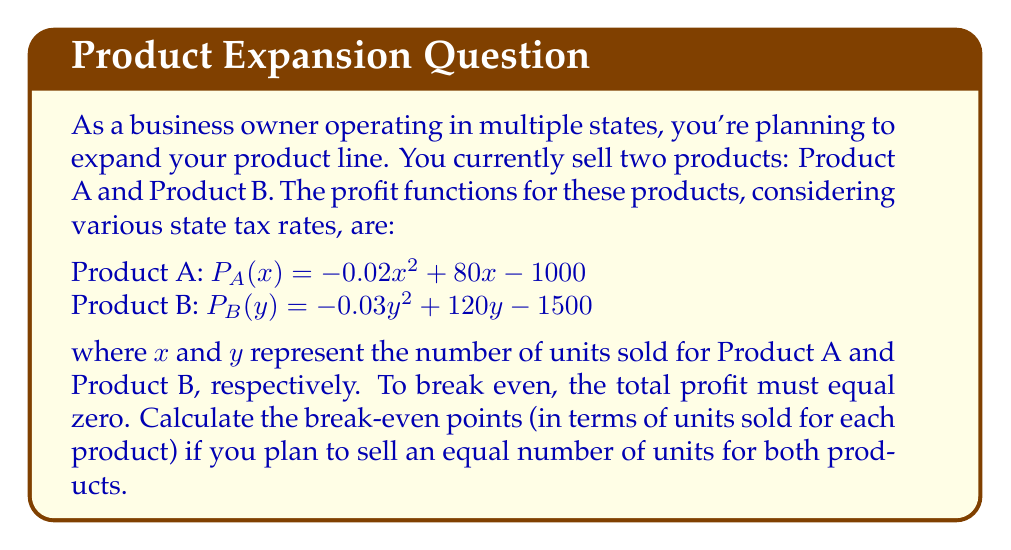Help me with this question. Let's approach this step-by-step:

1) We need to find the values of $x$ and $y$ where the total profit is zero and $x = y$. This can be expressed as:

   $P_A(x) + P_B(y) = 0$ and $x = y$

2) Substituting the given profit functions:

   $(-0.02x^2 + 80x - 1000) + (-0.03y^2 + 120y - 1500) = 0$

3) Since $x = y$, we can replace $y$ with $x$:

   $(-0.02x^2 + 80x - 1000) + (-0.03x^2 + 120x - 1500) = 0$

4) Simplify by combining like terms:

   $-0.05x^2 + 200x - 2500 = 0$

5) This is a quadratic equation in the standard form $ax^2 + bx + c = 0$, where:
   $a = -0.05$, $b = 200$, and $c = -2500$

6) We can solve this using the quadratic formula: $x = \frac{-b \pm \sqrt{b^2 - 4ac}}{2a}$

7) Substituting the values:

   $x = \frac{-200 \pm \sqrt{200^2 - 4(-0.05)(-2500)}}{2(-0.05)}$

8) Simplifying:

   $x = \frac{-200 \pm \sqrt{40000 - 500}}{-0.1} = \frac{-200 \pm \sqrt{39500}}{-0.1}$

9) Calculating:

   $x \approx 22.36$ or $x \approx 3977.64$

10) Since we can't sell fractional units and the larger value is unrealistic for most businesses, we round down to the nearest whole number for the smaller value.

Therefore, the break-even point occurs when selling 22 units each of Product A and Product B.
Answer: 22 units each of Product A and B 